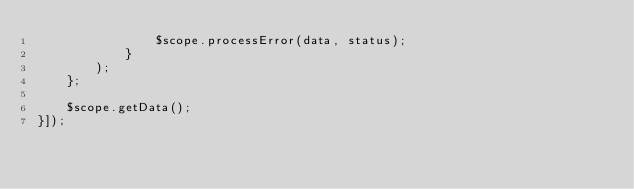Convert code to text. <code><loc_0><loc_0><loc_500><loc_500><_JavaScript_>                $scope.processError(data, status);
            }
        );
    };

    $scope.getData();
}]);</code> 